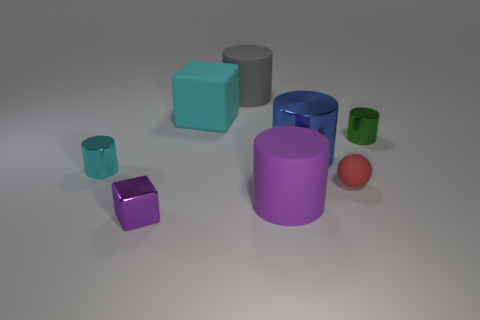What materials do the objects in the image appear to be made from? The objects in the image seem to have a matte finish and even lighting, suggesting they could be made of a plastic or some kind of non-reflective material. 